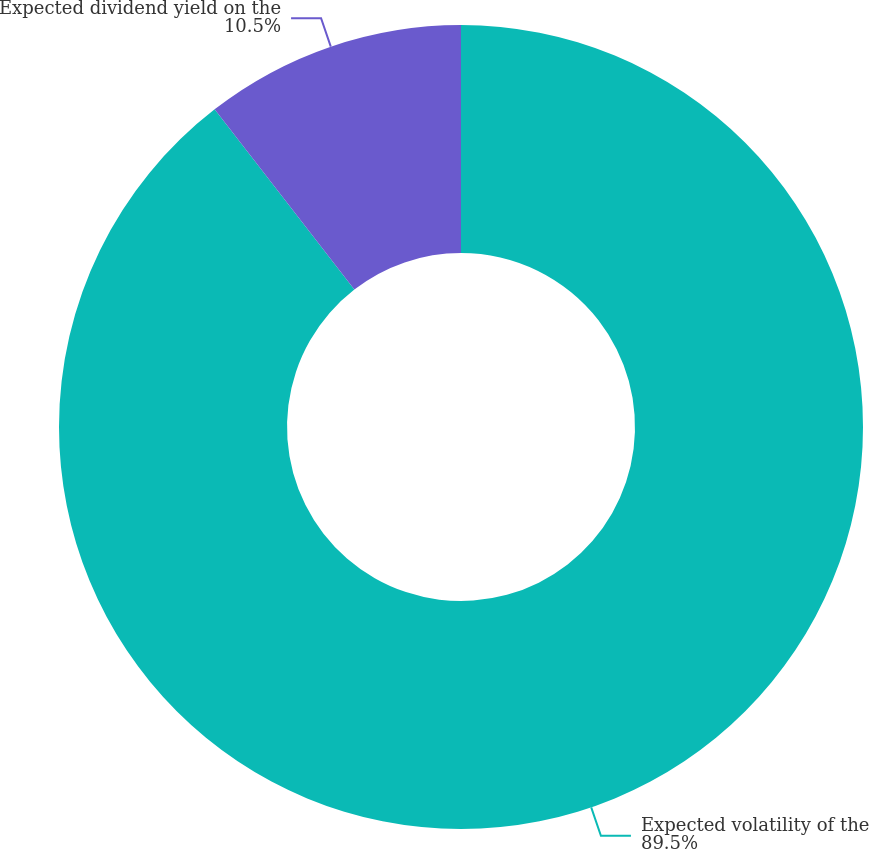Convert chart. <chart><loc_0><loc_0><loc_500><loc_500><pie_chart><fcel>Expected volatility of the<fcel>Expected dividend yield on the<nl><fcel>89.5%<fcel>10.5%<nl></chart> 